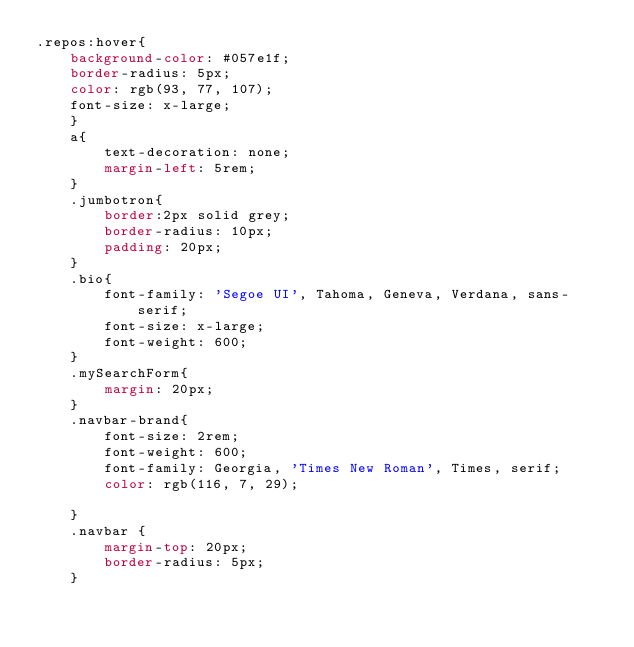<code> <loc_0><loc_0><loc_500><loc_500><_CSS_>.repos:hover{
    background-color: #057e1f;
    border-radius: 5px;
    color: rgb(93, 77, 107);
    font-size: x-large;
    }
    a{
        text-decoration: none;
        margin-left: 5rem;
    }
    .jumbotron{
        border:2px solid grey;
        border-radius: 10px;
        padding: 20px;
    }
    .bio{
        font-family: 'Segoe UI', Tahoma, Geneva, Verdana, sans-serif;
        font-size: x-large;
        font-weight: 600;
    }
    .mySearchForm{
        margin: 20px;
    }
    .navbar-brand{
        font-size: 2rem;
        font-weight: 600;
        font-family: Georgia, 'Times New Roman', Times, serif;
        color: rgb(116, 7, 29);
        
    }
    .navbar {
        margin-top: 20px;
        border-radius: 5px;
    }</code> 